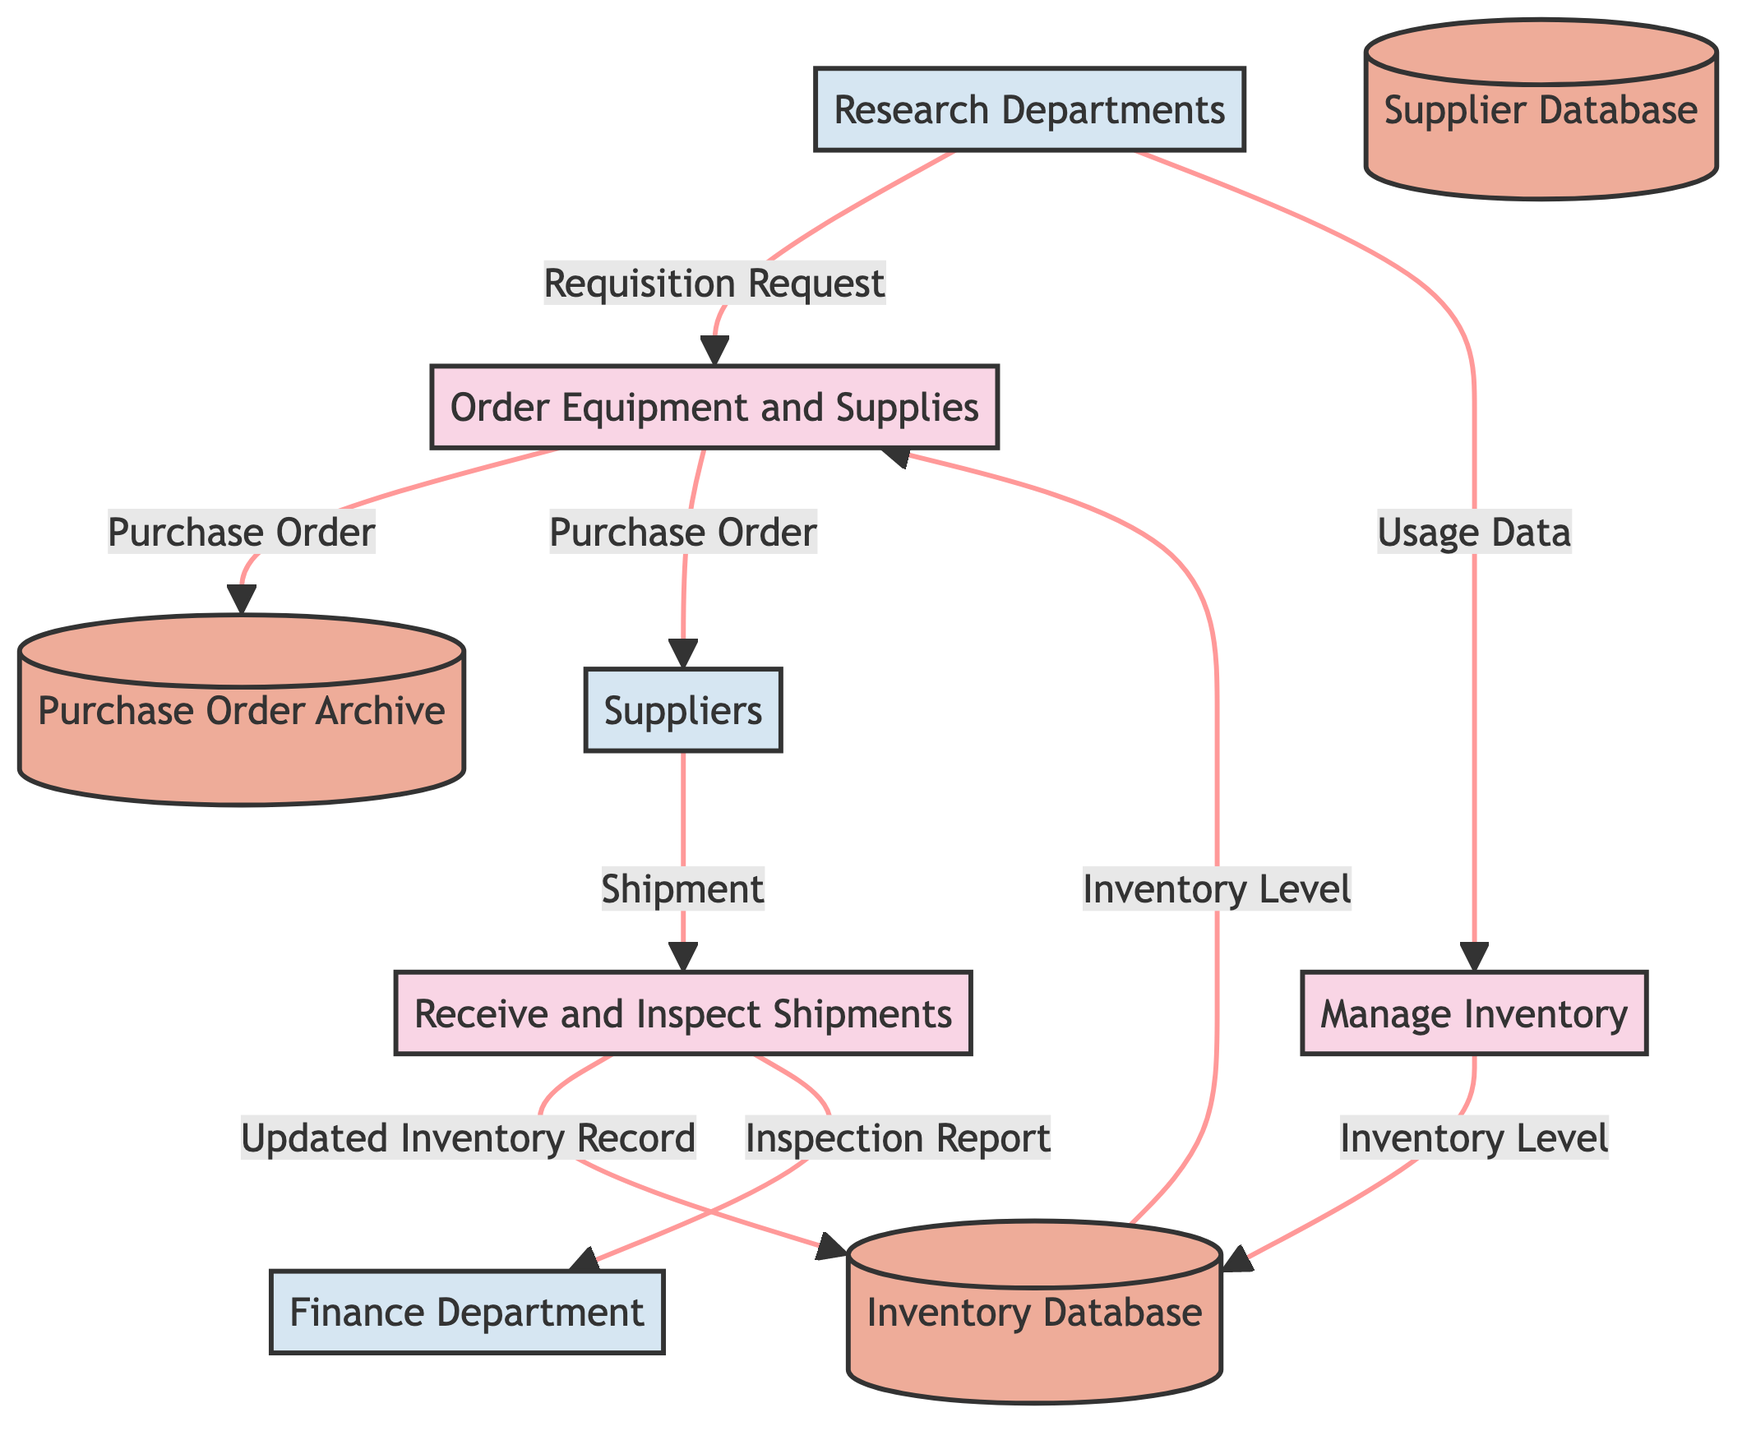What are the inputs for the "Manage Inventory" process? The "Manage Inventory" process has two inputs: "Updated Inventory Record" and "Usage Data," which are necessary to track and manage the inventory effectively.
Answer: Updated Inventory Record, Usage Data How many data stores are present in the diagram? The diagram includes three data stores, which are used to hold different types of data related to procurement and inventory management.
Answer: 3 What document is generated after the "Order Equipment and Supplies" process? The "Order Equipment and Supplies" process generates a "Purchase Order," which is used to request equipment and supplies from suppliers.
Answer: Purchase Order How does the "Receive and Inspect Shipments" process utilize the "Shipment" data flow? The "Receive and Inspect Shipments" process takes "Shipment" as an input from the suppliers to inspect the received goods and report on their condition and update inventory accordingly.
Answer: Inspect and update inventory Which external entity receives the "Inspection Report"? The "Inspection Report" is sent to the "Finance Department," which likely requires this information for financial oversight and records.
Answer: Finance Department What is the output of the "Receive and Inspect Shipments" process? The "Receive and Inspect Shipments" process produces two outputs: "Inspection Report" and "Updated Inventory Record," reflecting the results of the inspection and inventory updates.
Answer: Inspection Report, Updated Inventory Record Which process uses the "Inventory Level" data? The "Order Equipment and Supplies" process utilizes the "Inventory Level" data to decide whether to generate purchase orders based on the inventory status.
Answer: Order Equipment and Supplies What external entity initiates the procurement process? The "Research Departments" external entity initiates the procurement process by sending requisition requests for equipment and supplies needed for their research activities.
Answer: Research Departments 